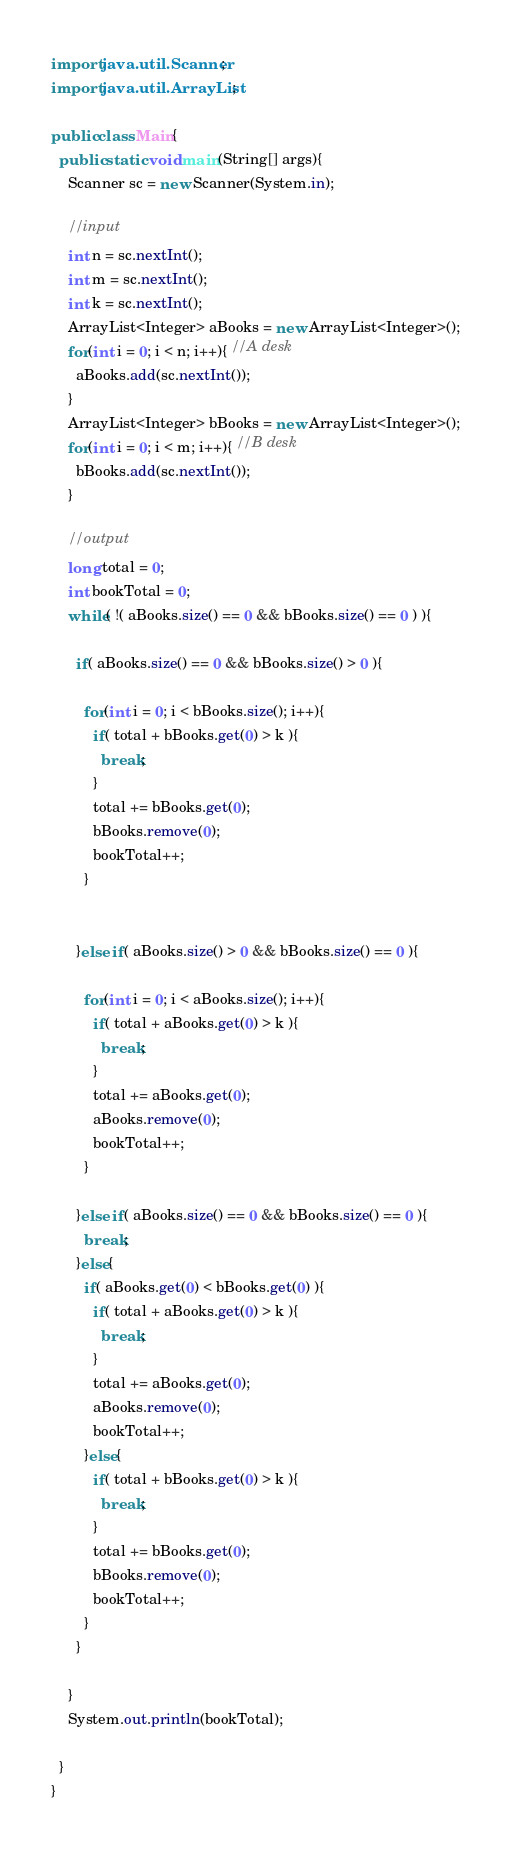Convert code to text. <code><loc_0><loc_0><loc_500><loc_500><_Java_>import java.util.Scanner;
import java.util.ArrayList;

public class Main{
  public static void main(String[] args){
    Scanner sc = new Scanner(System.in);

    //input
    int n = sc.nextInt();
    int m = sc.nextInt();
    int k = sc.nextInt();
    ArrayList<Integer> aBooks = new ArrayList<Integer>();
    for(int i = 0; i < n; i++){ //A desk
      aBooks.add(sc.nextInt());
    }
    ArrayList<Integer> bBooks = new ArrayList<Integer>();
    for(int i = 0; i < m; i++){ //B desk
      bBooks.add(sc.nextInt());
    }

    //output
    long total = 0;
    int bookTotal = 0;
    while( !( aBooks.size() == 0 && bBooks.size() == 0 ) ){

      if( aBooks.size() == 0 && bBooks.size() > 0 ){

        for(int i = 0; i < bBooks.size(); i++){
          if( total + bBooks.get(0) > k ){
            break;
          }
          total += bBooks.get(0);
          bBooks.remove(0);
          bookTotal++;
        }


      }else if( aBooks.size() > 0 && bBooks.size() == 0 ){

        for(int i = 0; i < aBooks.size(); i++){
          if( total + aBooks.get(0) > k ){
            break;
          }
          total += aBooks.get(0);
          aBooks.remove(0);
          bookTotal++;
        }

      }else if( aBooks.size() == 0 && bBooks.size() == 0 ){
        break;
      }else{
        if( aBooks.get(0) < bBooks.get(0) ){
          if( total + aBooks.get(0) > k ){
            break;
          }
          total += aBooks.get(0);
          aBooks.remove(0);
          bookTotal++;
        }else{
          if( total + bBooks.get(0) > k ){
            break;
          }
          total += bBooks.get(0);
          bBooks.remove(0);
          bookTotal++;
        }
      }

    }
    System.out.println(bookTotal);

  }
}
</code> 